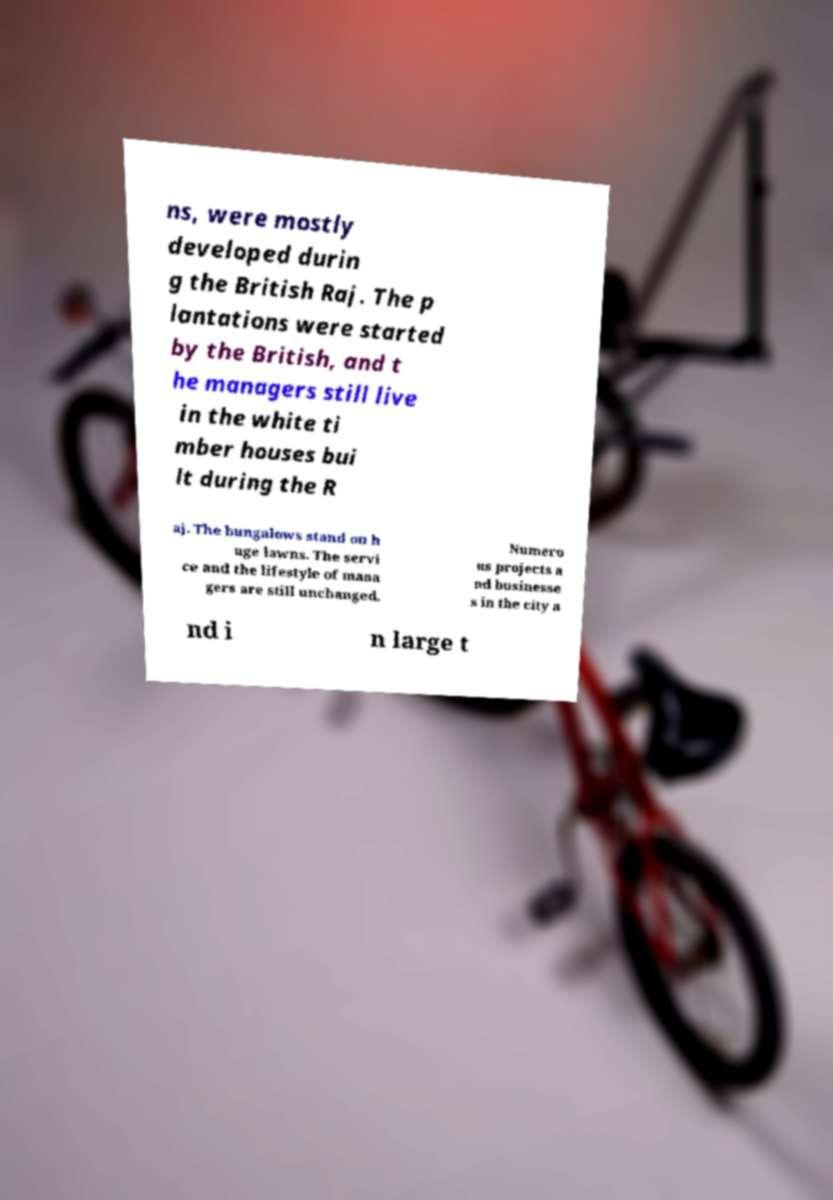I need the written content from this picture converted into text. Can you do that? ns, were mostly developed durin g the British Raj. The p lantations were started by the British, and t he managers still live in the white ti mber houses bui lt during the R aj. The bungalows stand on h uge lawns. The servi ce and the lifestyle of mana gers are still unchanged. Numero us projects a nd businesse s in the city a nd i n large t 